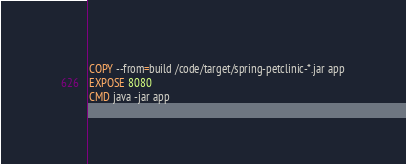Convert code to text. <code><loc_0><loc_0><loc_500><loc_500><_Dockerfile_>COPY --from=build /code/target/spring-petclinic-*.jar app
EXPOSE 8080 
CMD java -jar app 
</code> 